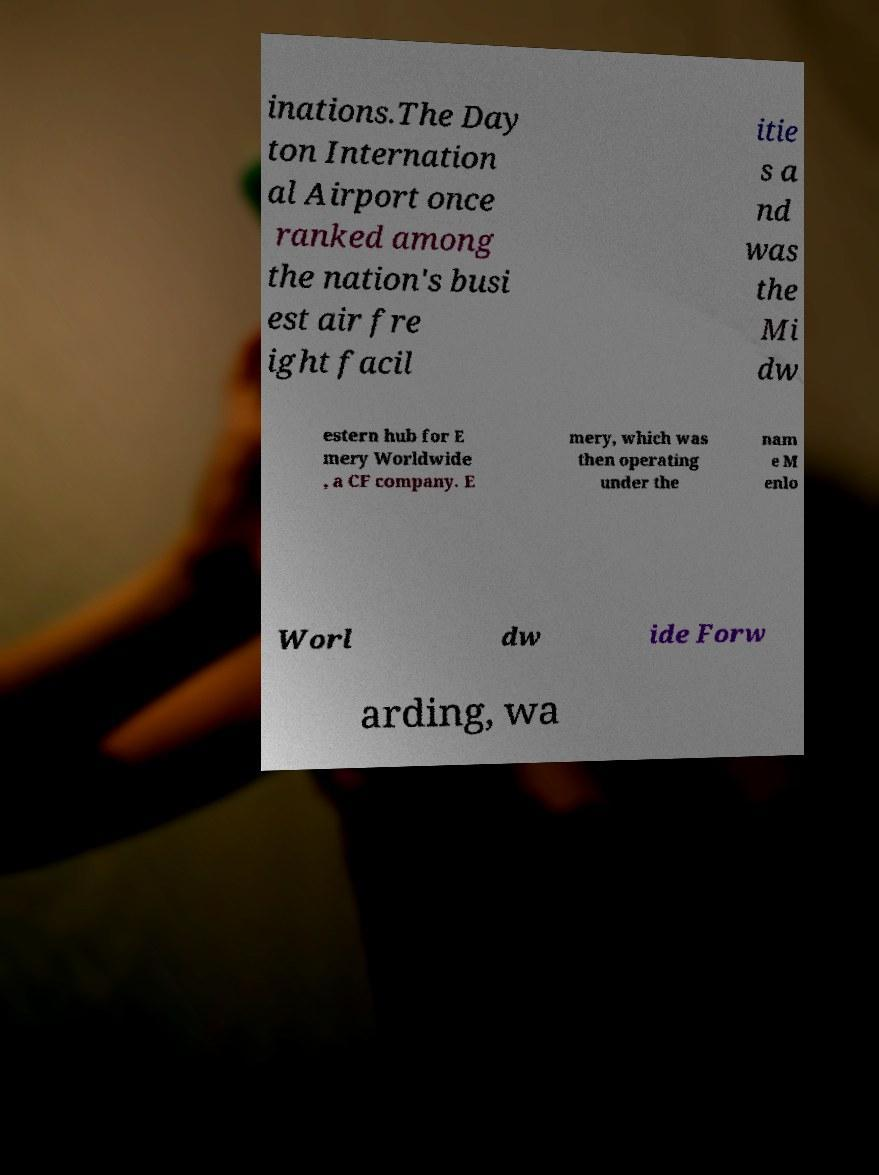What messages or text are displayed in this image? I need them in a readable, typed format. inations.The Day ton Internation al Airport once ranked among the nation's busi est air fre ight facil itie s a nd was the Mi dw estern hub for E mery Worldwide , a CF company. E mery, which was then operating under the nam e M enlo Worl dw ide Forw arding, wa 